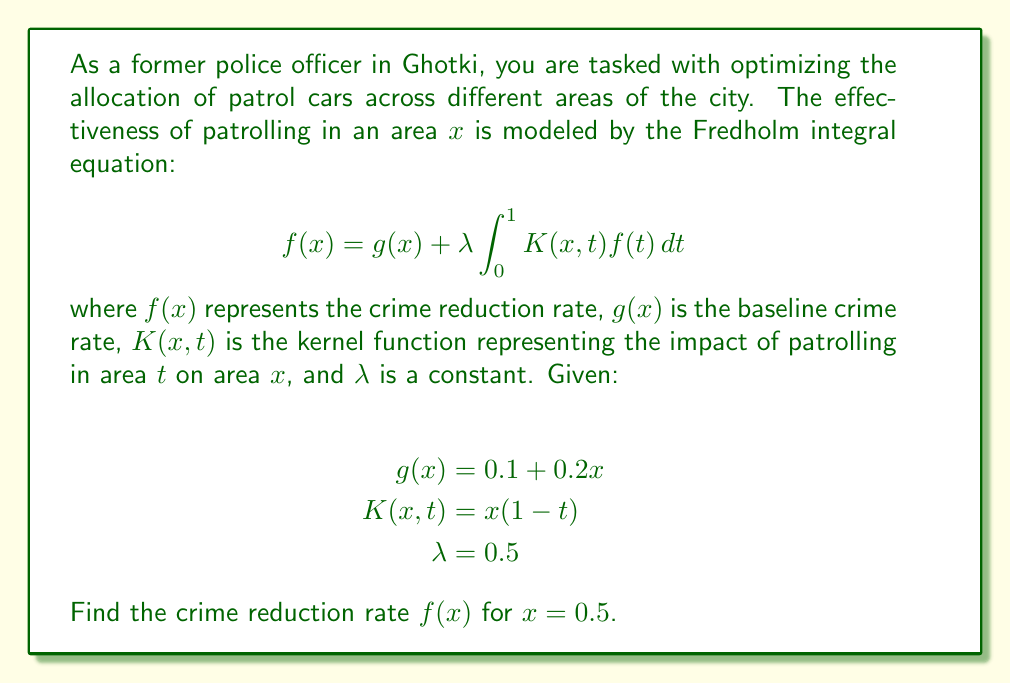Show me your answer to this math problem. To solve this Fredholm integral equation, we'll use the method of successive approximations:

1) Start with the initial approximation $f_0(x) = g(x) = 0.1 + 0.2x$

2) Use the recurrence relation:
   $$f_{n+1}(x) = g(x) + \lambda \int_0^1 K(x,t)f_n(t)dt$$

3) Let's calculate $f_1(x)$:
   $$f_1(x) = (0.1 + 0.2x) + 0.5 \int_0^1 x(1-t)(0.1 + 0.2t)dt$$
   
   $$= (0.1 + 0.2x) + 0.5x \int_0^1 (0.1 - 0.1t + 0.2t - 0.2t^2)dt$$
   
   $$= (0.1 + 0.2x) + 0.5x [0.1t - 0.05t^2 + 0.1t^2 - \frac{0.2}{3}t^3]_0^1$$
   
   $$= (0.1 + 0.2x) + 0.5x (0.1 - 0.05 + 0.1 - \frac{0.2}{3})$$
   
   $$= 0.1 + 0.2x + 0.075x$$
   
   $$= 0.1 + 0.275x$$

4) For $x = 0.5$:
   $$f_1(0.5) = 0.1 + 0.275(0.5) = 0.2375$$

5) We could continue this process to get more accurate results, but for the purpose of this question, we'll stop at the first approximation.
Answer: $f(0.5) \approx 0.2375$ 